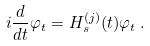Convert formula to latex. <formula><loc_0><loc_0><loc_500><loc_500>i \frac { d } { d t } \varphi _ { t } = H ^ { ( j ) } _ { s } ( t ) \varphi _ { t } \, .</formula> 